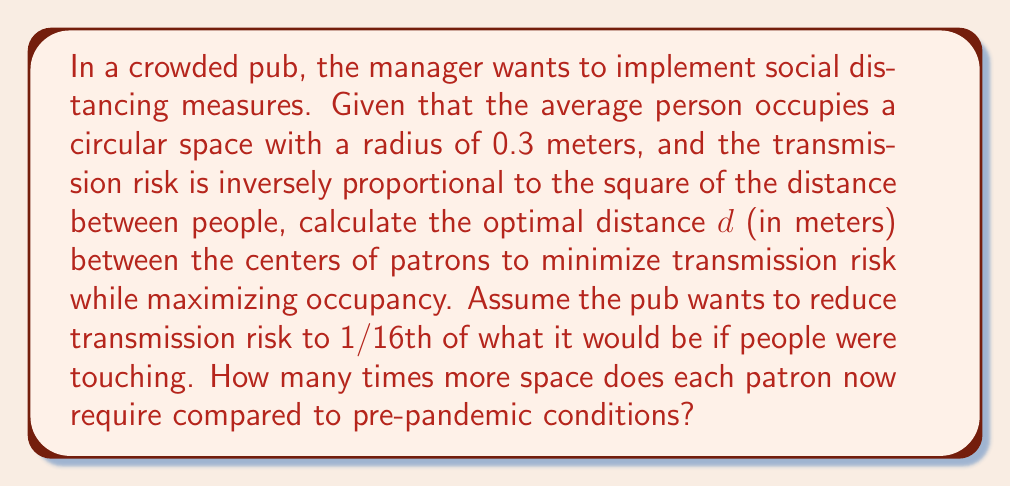Can you answer this question? Let's approach this step-by-step:

1) First, we need to establish the relationship between distance and transmission risk. If the risk is inversely proportional to the square of the distance, we can express it as:

   $$ \text{Risk} \propto \frac{1}{d^2} $$

2) We want to reduce the risk to 1/16th of what it would be if people were touching. When people are touching, the distance between their centers is twice the radius of the space they occupy:

   $$ d_{\text{touching}} = 2 \cdot 0.3 = 0.6 \text{ meters} $$

3) Let's call our optimal distance $d$. We can set up the following proportion:

   $$ \frac{1}{d^2} = \frac{1}{16} \cdot \frac{1}{(0.6)^2} $$

4) Solving for $d$:

   $$ d^2 = 16 \cdot (0.6)^2 = 16 \cdot 0.36 = 5.76 $$
   $$ d = \sqrt{5.76} = 2.4 \text{ meters} $$

5) To calculate how much more space each patron requires, we need to compare the areas:

   Pre-pandemic area: $A_1 = \pi r^2 = \pi \cdot (0.3)^2 = 0.2827 \text{ m}^2$
   
   Post-pandemic area: $A_2 = \pi r^2 = \pi \cdot (1.2)^2 = 4.5239 \text{ m}^2$

6) The ratio of new area to old area:

   $$ \frac{A_2}{A_1} = \frac{4.5239}{0.2827} = 16 $$

Therefore, each patron now requires 16 times more space than before.
Answer: The optimal distance between the centers of patrons is 2.4 meters, and each patron now requires 16 times more space compared to pre-pandemic conditions. 